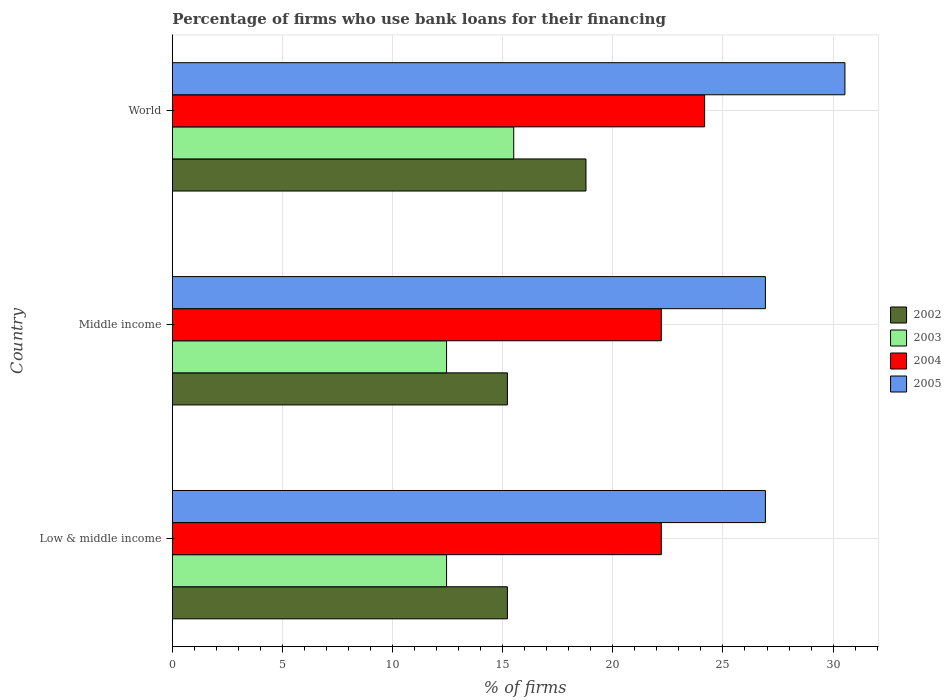How many different coloured bars are there?
Keep it short and to the point. 4. Are the number of bars per tick equal to the number of legend labels?
Provide a short and direct response. Yes. Are the number of bars on each tick of the Y-axis equal?
Make the answer very short. Yes. What is the label of the 3rd group of bars from the top?
Your answer should be very brief. Low & middle income. In how many cases, is the number of bars for a given country not equal to the number of legend labels?
Give a very brief answer. 0. What is the percentage of firms who use bank loans for their financing in 2004 in World?
Your answer should be compact. 24.17. Across all countries, what is the maximum percentage of firms who use bank loans for their financing in 2003?
Your response must be concise. 15.5. Across all countries, what is the minimum percentage of firms who use bank loans for their financing in 2004?
Offer a terse response. 22.2. In which country was the percentage of firms who use bank loans for their financing in 2004 maximum?
Provide a short and direct response. World. In which country was the percentage of firms who use bank loans for their financing in 2002 minimum?
Ensure brevity in your answer.  Low & middle income. What is the total percentage of firms who use bank loans for their financing in 2002 in the graph?
Your answer should be compact. 49.21. What is the difference between the percentage of firms who use bank loans for their financing in 2005 in Low & middle income and that in World?
Provide a short and direct response. -3.61. What is the difference between the percentage of firms who use bank loans for their financing in 2003 in Middle income and the percentage of firms who use bank loans for their financing in 2002 in Low & middle income?
Offer a terse response. -2.76. What is the average percentage of firms who use bank loans for their financing in 2003 per country?
Your answer should be very brief. 13.47. What is the difference between the percentage of firms who use bank loans for their financing in 2005 and percentage of firms who use bank loans for their financing in 2002 in Low & middle income?
Make the answer very short. 11.72. What is the ratio of the percentage of firms who use bank loans for their financing in 2004 in Low & middle income to that in World?
Keep it short and to the point. 0.92. Is the percentage of firms who use bank loans for their financing in 2004 in Low & middle income less than that in Middle income?
Keep it short and to the point. No. What is the difference between the highest and the second highest percentage of firms who use bank loans for their financing in 2005?
Your answer should be very brief. 3.61. What is the difference between the highest and the lowest percentage of firms who use bank loans for their financing in 2002?
Ensure brevity in your answer.  3.57. Is the sum of the percentage of firms who use bank loans for their financing in 2003 in Low & middle income and World greater than the maximum percentage of firms who use bank loans for their financing in 2005 across all countries?
Provide a short and direct response. No. Is it the case that in every country, the sum of the percentage of firms who use bank loans for their financing in 2004 and percentage of firms who use bank loans for their financing in 2005 is greater than the percentage of firms who use bank loans for their financing in 2003?
Offer a terse response. Yes. How many bars are there?
Offer a terse response. 12. Are all the bars in the graph horizontal?
Provide a short and direct response. Yes. How many countries are there in the graph?
Provide a short and direct response. 3. Are the values on the major ticks of X-axis written in scientific E-notation?
Offer a terse response. No. How are the legend labels stacked?
Give a very brief answer. Vertical. What is the title of the graph?
Make the answer very short. Percentage of firms who use bank loans for their financing. Does "1969" appear as one of the legend labels in the graph?
Ensure brevity in your answer.  No. What is the label or title of the X-axis?
Offer a terse response. % of firms. What is the label or title of the Y-axis?
Make the answer very short. Country. What is the % of firms in 2002 in Low & middle income?
Your response must be concise. 15.21. What is the % of firms in 2003 in Low & middle income?
Offer a terse response. 12.45. What is the % of firms in 2005 in Low & middle income?
Offer a terse response. 26.93. What is the % of firms in 2002 in Middle income?
Make the answer very short. 15.21. What is the % of firms in 2003 in Middle income?
Your answer should be compact. 12.45. What is the % of firms in 2004 in Middle income?
Make the answer very short. 22.2. What is the % of firms of 2005 in Middle income?
Give a very brief answer. 26.93. What is the % of firms of 2002 in World?
Provide a succinct answer. 18.78. What is the % of firms in 2003 in World?
Provide a succinct answer. 15.5. What is the % of firms in 2004 in World?
Your answer should be compact. 24.17. What is the % of firms in 2005 in World?
Offer a very short reply. 30.54. Across all countries, what is the maximum % of firms in 2002?
Keep it short and to the point. 18.78. Across all countries, what is the maximum % of firms in 2003?
Your answer should be very brief. 15.5. Across all countries, what is the maximum % of firms in 2004?
Give a very brief answer. 24.17. Across all countries, what is the maximum % of firms in 2005?
Offer a very short reply. 30.54. Across all countries, what is the minimum % of firms in 2002?
Your answer should be very brief. 15.21. Across all countries, what is the minimum % of firms in 2003?
Your answer should be compact. 12.45. Across all countries, what is the minimum % of firms of 2005?
Make the answer very short. 26.93. What is the total % of firms of 2002 in the graph?
Your response must be concise. 49.21. What is the total % of firms in 2003 in the graph?
Give a very brief answer. 40.4. What is the total % of firms in 2004 in the graph?
Provide a succinct answer. 68.57. What is the total % of firms of 2005 in the graph?
Offer a very short reply. 84.39. What is the difference between the % of firms of 2004 in Low & middle income and that in Middle income?
Offer a very short reply. 0. What is the difference between the % of firms of 2005 in Low & middle income and that in Middle income?
Offer a very short reply. 0. What is the difference between the % of firms of 2002 in Low & middle income and that in World?
Keep it short and to the point. -3.57. What is the difference between the % of firms in 2003 in Low & middle income and that in World?
Your answer should be very brief. -3.05. What is the difference between the % of firms in 2004 in Low & middle income and that in World?
Your response must be concise. -1.97. What is the difference between the % of firms of 2005 in Low & middle income and that in World?
Offer a very short reply. -3.61. What is the difference between the % of firms in 2002 in Middle income and that in World?
Make the answer very short. -3.57. What is the difference between the % of firms in 2003 in Middle income and that in World?
Keep it short and to the point. -3.05. What is the difference between the % of firms of 2004 in Middle income and that in World?
Ensure brevity in your answer.  -1.97. What is the difference between the % of firms of 2005 in Middle income and that in World?
Ensure brevity in your answer.  -3.61. What is the difference between the % of firms of 2002 in Low & middle income and the % of firms of 2003 in Middle income?
Your response must be concise. 2.76. What is the difference between the % of firms of 2002 in Low & middle income and the % of firms of 2004 in Middle income?
Your answer should be very brief. -6.99. What is the difference between the % of firms in 2002 in Low & middle income and the % of firms in 2005 in Middle income?
Offer a terse response. -11.72. What is the difference between the % of firms of 2003 in Low & middle income and the % of firms of 2004 in Middle income?
Ensure brevity in your answer.  -9.75. What is the difference between the % of firms of 2003 in Low & middle income and the % of firms of 2005 in Middle income?
Give a very brief answer. -14.48. What is the difference between the % of firms of 2004 in Low & middle income and the % of firms of 2005 in Middle income?
Your answer should be compact. -4.73. What is the difference between the % of firms in 2002 in Low & middle income and the % of firms in 2003 in World?
Give a very brief answer. -0.29. What is the difference between the % of firms of 2002 in Low & middle income and the % of firms of 2004 in World?
Provide a succinct answer. -8.95. What is the difference between the % of firms in 2002 in Low & middle income and the % of firms in 2005 in World?
Offer a terse response. -15.33. What is the difference between the % of firms of 2003 in Low & middle income and the % of firms of 2004 in World?
Provide a succinct answer. -11.72. What is the difference between the % of firms in 2003 in Low & middle income and the % of firms in 2005 in World?
Your answer should be very brief. -18.09. What is the difference between the % of firms of 2004 in Low & middle income and the % of firms of 2005 in World?
Make the answer very short. -8.34. What is the difference between the % of firms of 2002 in Middle income and the % of firms of 2003 in World?
Provide a succinct answer. -0.29. What is the difference between the % of firms in 2002 in Middle income and the % of firms in 2004 in World?
Offer a very short reply. -8.95. What is the difference between the % of firms of 2002 in Middle income and the % of firms of 2005 in World?
Your response must be concise. -15.33. What is the difference between the % of firms of 2003 in Middle income and the % of firms of 2004 in World?
Give a very brief answer. -11.72. What is the difference between the % of firms of 2003 in Middle income and the % of firms of 2005 in World?
Provide a succinct answer. -18.09. What is the difference between the % of firms in 2004 in Middle income and the % of firms in 2005 in World?
Offer a terse response. -8.34. What is the average % of firms of 2002 per country?
Your answer should be very brief. 16.4. What is the average % of firms of 2003 per country?
Offer a terse response. 13.47. What is the average % of firms in 2004 per country?
Your answer should be very brief. 22.86. What is the average % of firms of 2005 per country?
Offer a very short reply. 28.13. What is the difference between the % of firms of 2002 and % of firms of 2003 in Low & middle income?
Give a very brief answer. 2.76. What is the difference between the % of firms of 2002 and % of firms of 2004 in Low & middle income?
Your response must be concise. -6.99. What is the difference between the % of firms in 2002 and % of firms in 2005 in Low & middle income?
Offer a very short reply. -11.72. What is the difference between the % of firms in 2003 and % of firms in 2004 in Low & middle income?
Provide a short and direct response. -9.75. What is the difference between the % of firms of 2003 and % of firms of 2005 in Low & middle income?
Your answer should be very brief. -14.48. What is the difference between the % of firms of 2004 and % of firms of 2005 in Low & middle income?
Give a very brief answer. -4.73. What is the difference between the % of firms in 2002 and % of firms in 2003 in Middle income?
Offer a very short reply. 2.76. What is the difference between the % of firms of 2002 and % of firms of 2004 in Middle income?
Your response must be concise. -6.99. What is the difference between the % of firms of 2002 and % of firms of 2005 in Middle income?
Offer a terse response. -11.72. What is the difference between the % of firms in 2003 and % of firms in 2004 in Middle income?
Your response must be concise. -9.75. What is the difference between the % of firms in 2003 and % of firms in 2005 in Middle income?
Ensure brevity in your answer.  -14.48. What is the difference between the % of firms of 2004 and % of firms of 2005 in Middle income?
Keep it short and to the point. -4.73. What is the difference between the % of firms of 2002 and % of firms of 2003 in World?
Keep it short and to the point. 3.28. What is the difference between the % of firms in 2002 and % of firms in 2004 in World?
Your response must be concise. -5.39. What is the difference between the % of firms of 2002 and % of firms of 2005 in World?
Keep it short and to the point. -11.76. What is the difference between the % of firms of 2003 and % of firms of 2004 in World?
Your answer should be compact. -8.67. What is the difference between the % of firms in 2003 and % of firms in 2005 in World?
Provide a short and direct response. -15.04. What is the difference between the % of firms in 2004 and % of firms in 2005 in World?
Keep it short and to the point. -6.37. What is the ratio of the % of firms of 2003 in Low & middle income to that in Middle income?
Ensure brevity in your answer.  1. What is the ratio of the % of firms of 2004 in Low & middle income to that in Middle income?
Offer a very short reply. 1. What is the ratio of the % of firms of 2002 in Low & middle income to that in World?
Offer a terse response. 0.81. What is the ratio of the % of firms of 2003 in Low & middle income to that in World?
Offer a very short reply. 0.8. What is the ratio of the % of firms of 2004 in Low & middle income to that in World?
Ensure brevity in your answer.  0.92. What is the ratio of the % of firms in 2005 in Low & middle income to that in World?
Your response must be concise. 0.88. What is the ratio of the % of firms of 2002 in Middle income to that in World?
Offer a very short reply. 0.81. What is the ratio of the % of firms of 2003 in Middle income to that in World?
Give a very brief answer. 0.8. What is the ratio of the % of firms in 2004 in Middle income to that in World?
Make the answer very short. 0.92. What is the ratio of the % of firms of 2005 in Middle income to that in World?
Provide a short and direct response. 0.88. What is the difference between the highest and the second highest % of firms of 2002?
Give a very brief answer. 3.57. What is the difference between the highest and the second highest % of firms of 2003?
Give a very brief answer. 3.05. What is the difference between the highest and the second highest % of firms in 2004?
Give a very brief answer. 1.97. What is the difference between the highest and the second highest % of firms in 2005?
Give a very brief answer. 3.61. What is the difference between the highest and the lowest % of firms in 2002?
Provide a succinct answer. 3.57. What is the difference between the highest and the lowest % of firms in 2003?
Offer a terse response. 3.05. What is the difference between the highest and the lowest % of firms of 2004?
Keep it short and to the point. 1.97. What is the difference between the highest and the lowest % of firms of 2005?
Give a very brief answer. 3.61. 